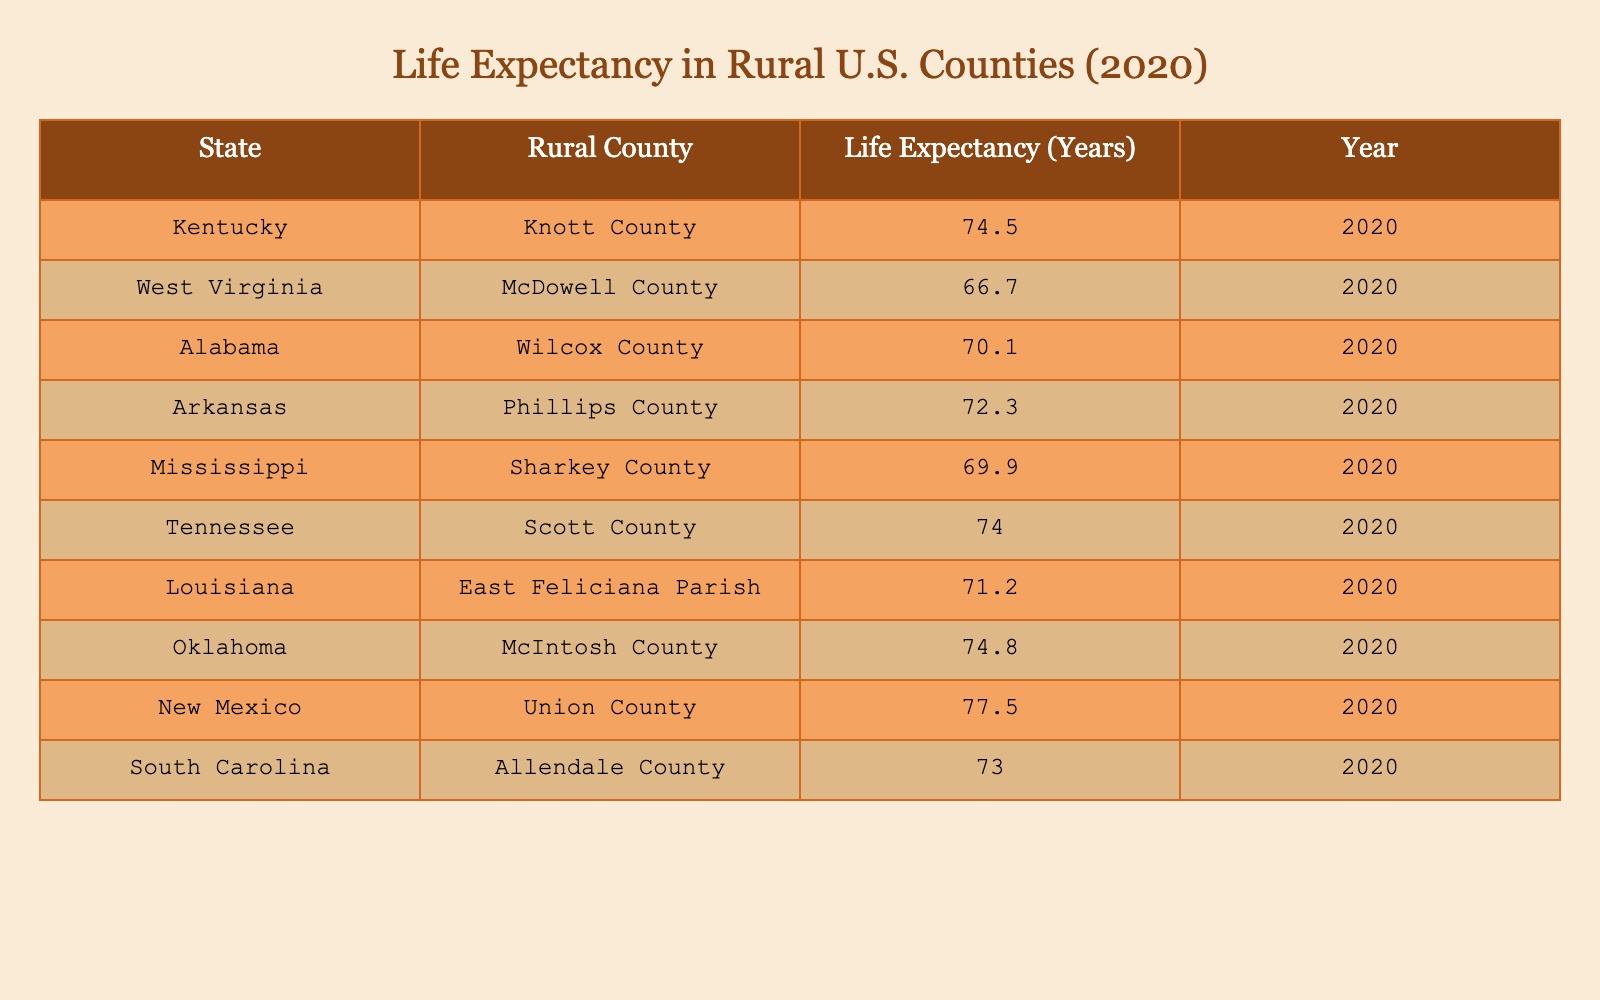What is the life expectancy in Knott County, Kentucky? The table directly lists a life expectancy of 74.5 years for Knott County, Kentucky in 2020.
Answer: 74.5 years Which rural county in the U.S. has the lowest life expectancy in 2020? Referring to the table, McDowell County, West Virginia has the lowest life expectancy at 66.7 years in 2020.
Answer: McDowell County, West Virginia What is the average life expectancy of the rural counties listed in Alabama? The life expectancies for Alabama rural counties are available: Wilcox County (70.1 years). Since Wilcox County is the only county listed, the average is also 70.1 years.
Answer: 70.1 years What is the difference in life expectancy between Union County, New Mexico and Allendale County, South Carolina? Union County has a life expectancy of 77.5 years and Allendale County has 73.0 years. The difference is 77.5 - 73.0 = 4.5 years.
Answer: 4.5 years Is the life expectancy in East Feliciana Parish, Louisiana greater than 70 years? The table shows that East Feliciana Parish has a life expectancy of 71.2 years, which is indeed greater than 70 years.
Answer: Yes Which states have rural counties with a life expectancy greater than 75 years in 2020? Examining the table, the states with rural counties having a life expectancy greater than 75 years are New Mexico (Union County with 77.5 years) and Oklahoma (McIntosh County with 74.8 years).
Answer: New Mexico and Oklahoma If you combined the life expectancies of all the rural counties listed, what would be the total? Summing the life expectancies: 74.5 + 66.7 + 70.1 + 72.3 + 69.9 + 74.0 + 71.2 + 74.8 + 77.5 + 73.0 =  724.0 years.
Answer: 724.0 years What percentage of rural counties in the table have a life expectancy below 72 years? There are 10 counties in total. The following counties have life expectancies below 72 years: McDowell County (66.7), Wilcox County (70.1), Phillips County (72.3), and Sharkey County (69.9)—totaling 4 counties. Thus, the percentage is (4/10)*100 = 40%.
Answer: 40% Which county has a life expectancy closest to the average life expectancy of the counties listed? To find the average, sum the life expectancies (724.0 years) and divide by 10, giving an average life expectancy of 72.4 years. The closest value is Phillips County with a life expectancy of 72.3 years.
Answer: Phillips County 